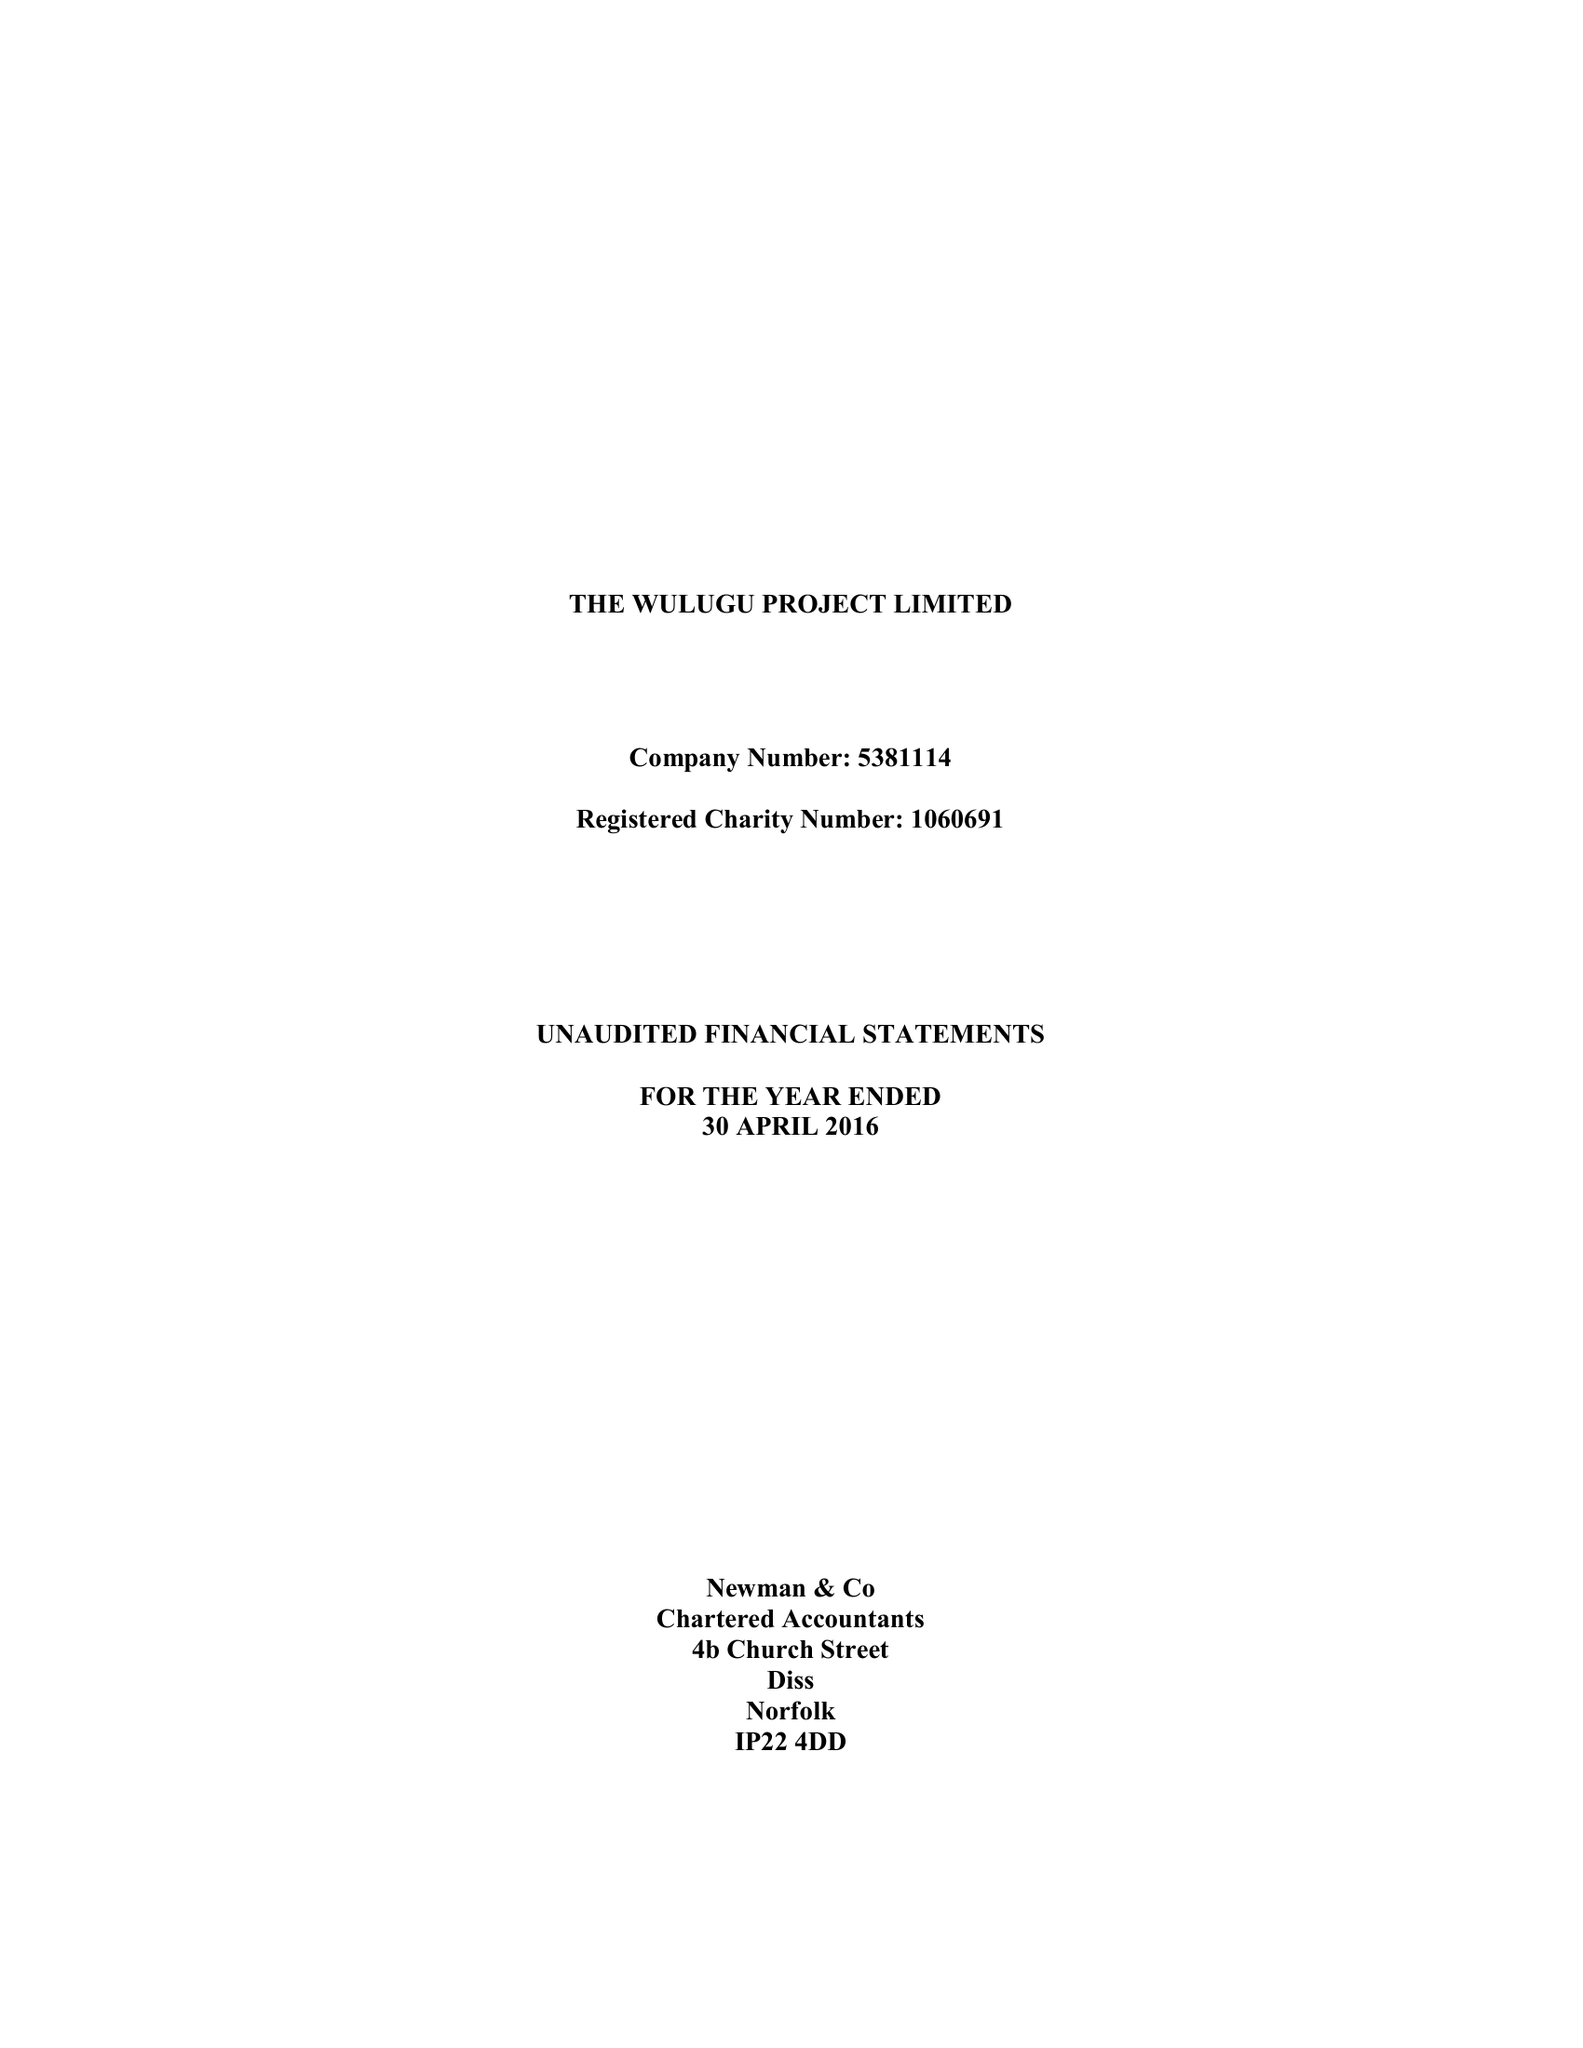What is the value for the charity_name?
Answer the question using a single word or phrase. The Wulugu Project Ltd. 